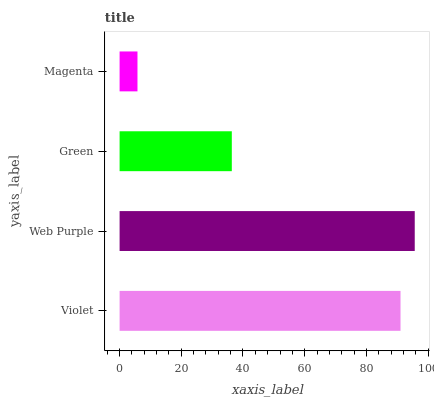Is Magenta the minimum?
Answer yes or no. Yes. Is Web Purple the maximum?
Answer yes or no. Yes. Is Green the minimum?
Answer yes or no. No. Is Green the maximum?
Answer yes or no. No. Is Web Purple greater than Green?
Answer yes or no. Yes. Is Green less than Web Purple?
Answer yes or no. Yes. Is Green greater than Web Purple?
Answer yes or no. No. Is Web Purple less than Green?
Answer yes or no. No. Is Violet the high median?
Answer yes or no. Yes. Is Green the low median?
Answer yes or no. Yes. Is Green the high median?
Answer yes or no. No. Is Web Purple the low median?
Answer yes or no. No. 